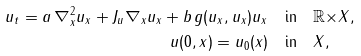Convert formula to latex. <formula><loc_0><loc_0><loc_500><loc_500>u _ { t } = a \, \nabla _ { x } ^ { 2 } u _ { x } + J _ { u } \nabla _ { x } u _ { x } + b \, g ( u _ { x } , u _ { x } ) u _ { x } & \quad \text {in} \quad \mathbb { R } { \times } X , \\ u ( 0 , x ) = u _ { 0 } ( x ) & \quad \text {in} \quad X ,</formula> 